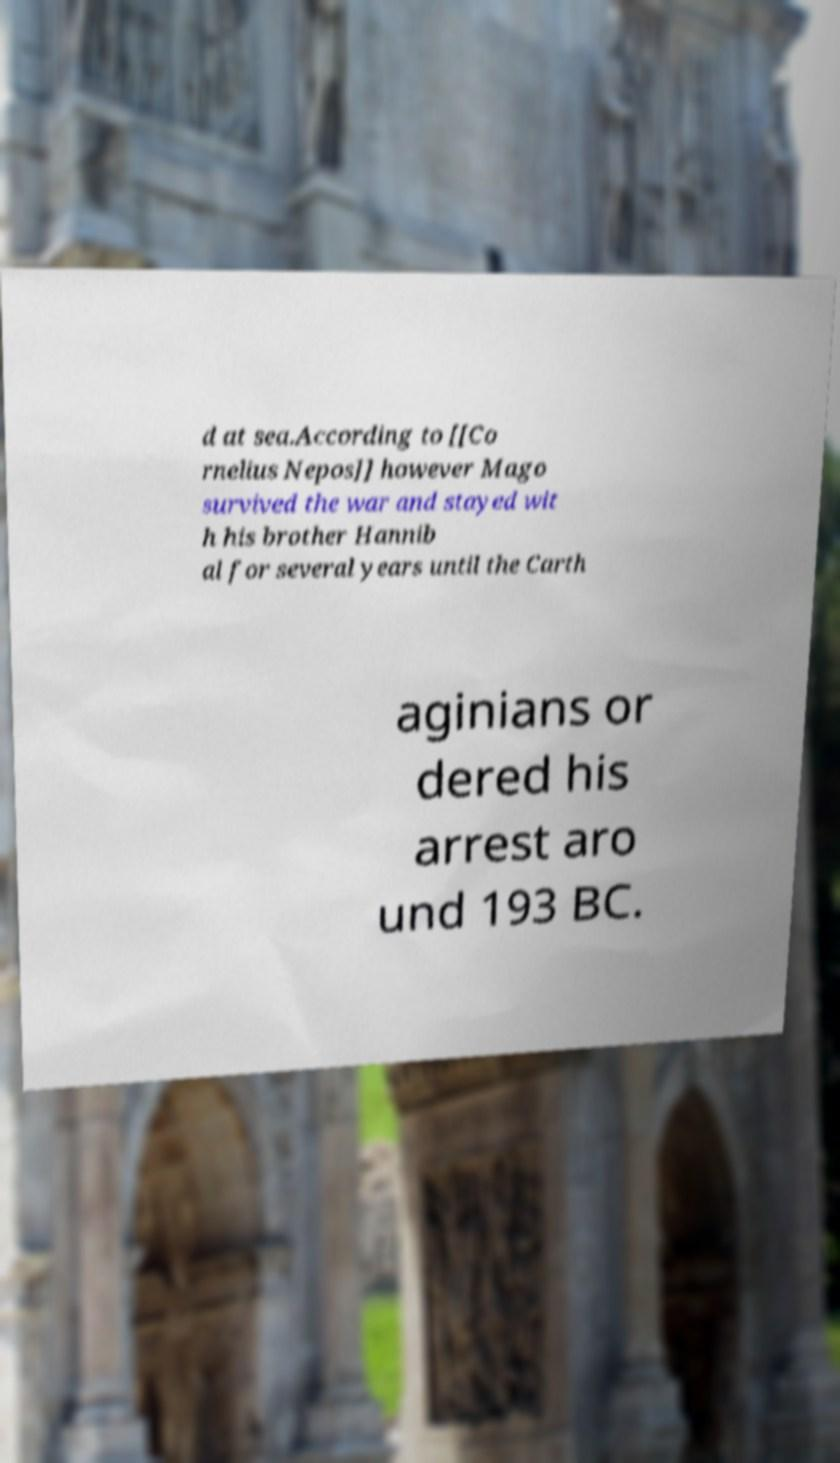Can you read and provide the text displayed in the image?This photo seems to have some interesting text. Can you extract and type it out for me? d at sea.According to [[Co rnelius Nepos]] however Mago survived the war and stayed wit h his brother Hannib al for several years until the Carth aginians or dered his arrest aro und 193 BC. 